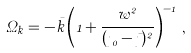<formula> <loc_0><loc_0><loc_500><loc_500>\Omega _ { k } = - \bar { k } \left ( 1 + \frac { w ^ { 2 } } { ( \eta _ { 0 } - \bar { \eta } ) ^ { 2 } } \right ) ^ { - 1 } \, ,</formula> 